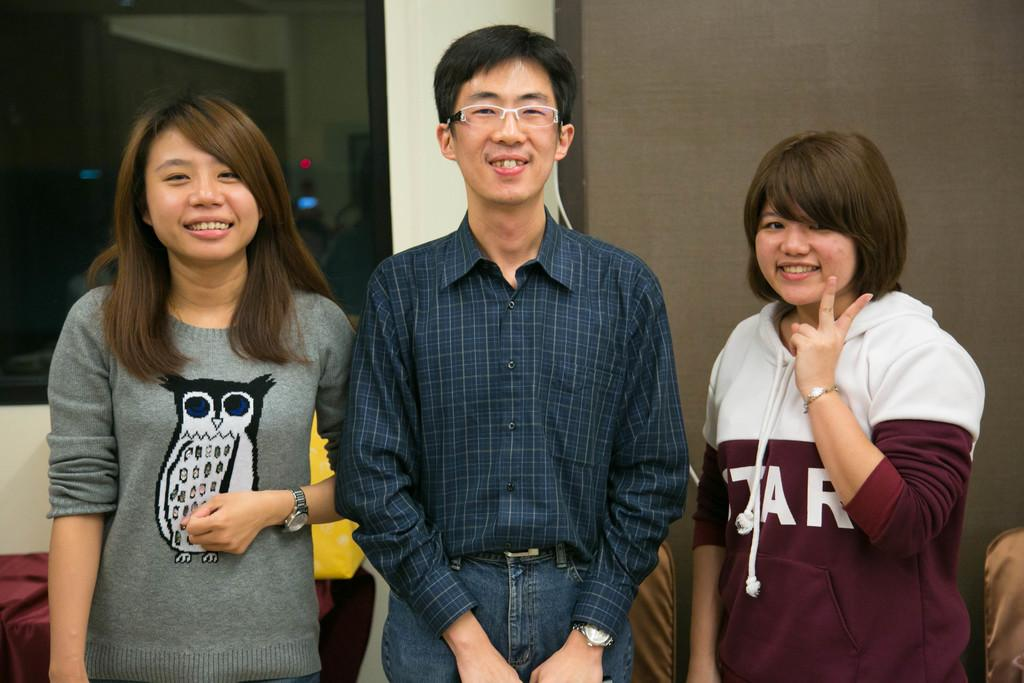How many people are in the image? There are three people in the image: one man and two women. What are the people in the image doing? The man and women are standing. What is visible behind the people in the image? There is a wall behind them. What type of coil is being used by the cat in the image? There is no cat or coil present in the image. How many tickets can be seen in the hands of the people in the image? There is no mention of tickets in the image; it only features a man and two women standing. 